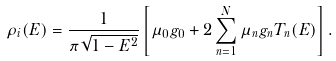Convert formula to latex. <formula><loc_0><loc_0><loc_500><loc_500>\rho _ { i } ( E ) = \frac { 1 } { \pi \sqrt { 1 - E ^ { 2 } } } \left [ \mu _ { 0 } g _ { 0 } + 2 \sum _ { n = 1 } ^ { N } \mu _ { n } g _ { n } T _ { n } ( E ) \right ] .</formula> 